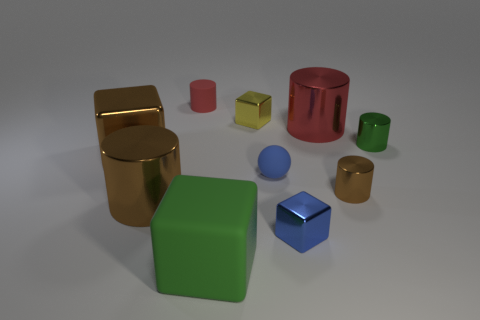What number of objects are both to the left of the small brown metallic cylinder and to the right of the small brown metallic cylinder?
Give a very brief answer. 0. How many yellow cubes are made of the same material as the blue ball?
Keep it short and to the point. 0. What color is the big block that is made of the same material as the small blue ball?
Your answer should be compact. Green. Is the number of gray rubber things less than the number of big green blocks?
Make the answer very short. Yes. What is the brown thing right of the small metal cube in front of the brown cylinder left of the small yellow metallic object made of?
Offer a terse response. Metal. What is the large brown cylinder made of?
Ensure brevity in your answer.  Metal. Do the large cylinder that is to the right of the tiny red cylinder and the small rubber object that is right of the green matte thing have the same color?
Give a very brief answer. No. Are there more small gray rubber cylinders than tiny red matte things?
Your response must be concise. No. How many metal things have the same color as the sphere?
Your answer should be very brief. 1. What color is the large matte thing that is the same shape as the yellow metallic object?
Provide a short and direct response. Green. 